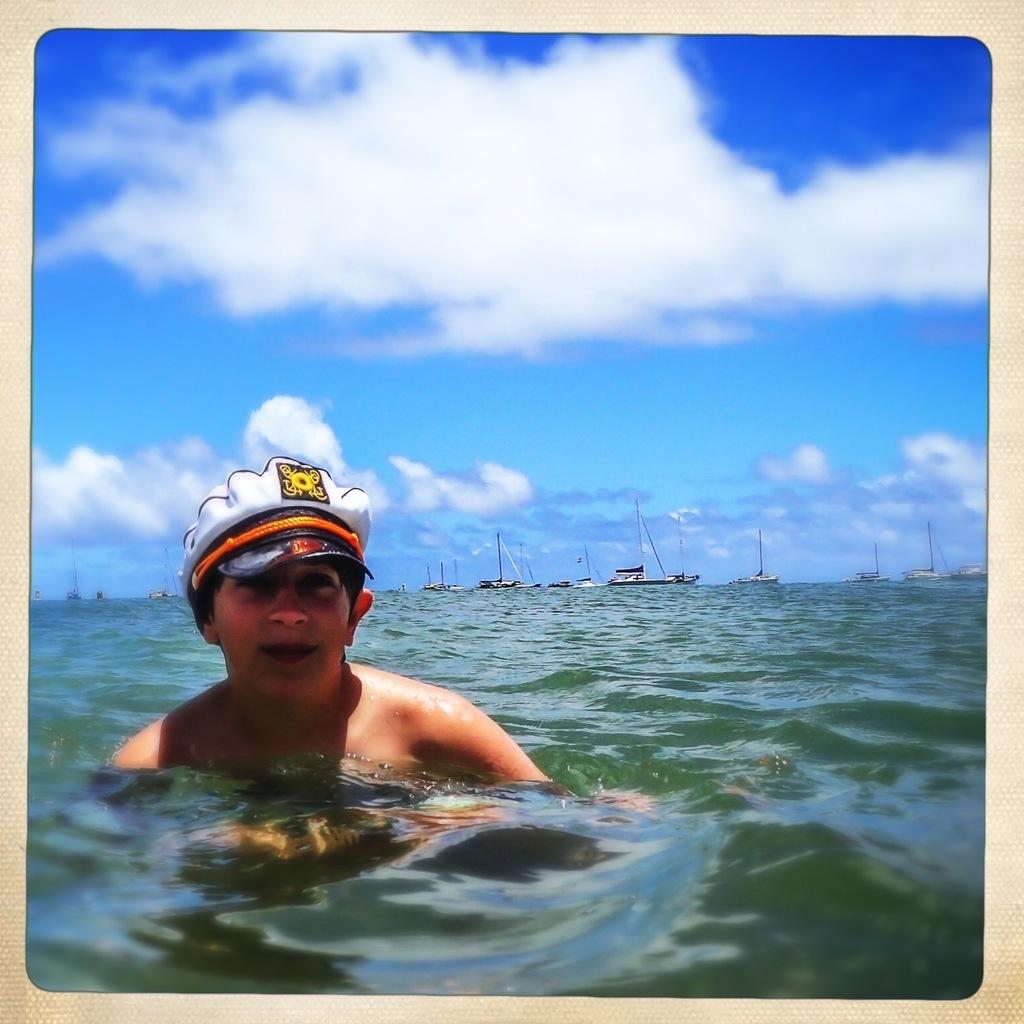What is the person in the water wearing? The person is wearing a cap. What can be seen in the background of the image? There are boats in the background of the image. What part of the natural environment is visible in the image? The sky is visible in the image. What is the condition of the sky in the image? The sky has clouds in the image. What type of metal is being used in the industrial process depicted in the image? There is no industrial process or metal present in the image; it features a person wearing a cap in the water with boats in the background and clouds in the sky. 